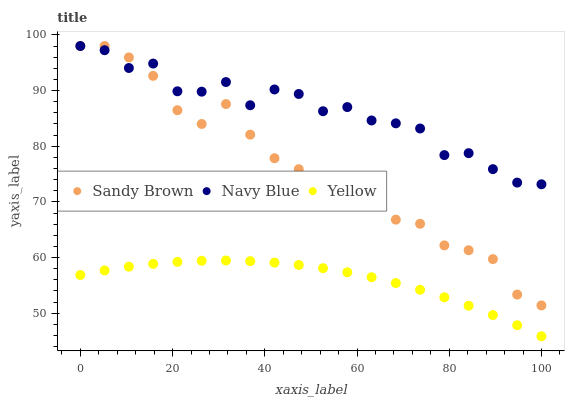Does Yellow have the minimum area under the curve?
Answer yes or no. Yes. Does Navy Blue have the maximum area under the curve?
Answer yes or no. Yes. Does Sandy Brown have the minimum area under the curve?
Answer yes or no. No. Does Sandy Brown have the maximum area under the curve?
Answer yes or no. No. Is Yellow the smoothest?
Answer yes or no. Yes. Is Sandy Brown the roughest?
Answer yes or no. Yes. Is Sandy Brown the smoothest?
Answer yes or no. No. Is Yellow the roughest?
Answer yes or no. No. Does Yellow have the lowest value?
Answer yes or no. Yes. Does Sandy Brown have the lowest value?
Answer yes or no. No. Does Sandy Brown have the highest value?
Answer yes or no. Yes. Does Yellow have the highest value?
Answer yes or no. No. Is Yellow less than Navy Blue?
Answer yes or no. Yes. Is Sandy Brown greater than Yellow?
Answer yes or no. Yes. Does Navy Blue intersect Sandy Brown?
Answer yes or no. Yes. Is Navy Blue less than Sandy Brown?
Answer yes or no. No. Is Navy Blue greater than Sandy Brown?
Answer yes or no. No. Does Yellow intersect Navy Blue?
Answer yes or no. No. 